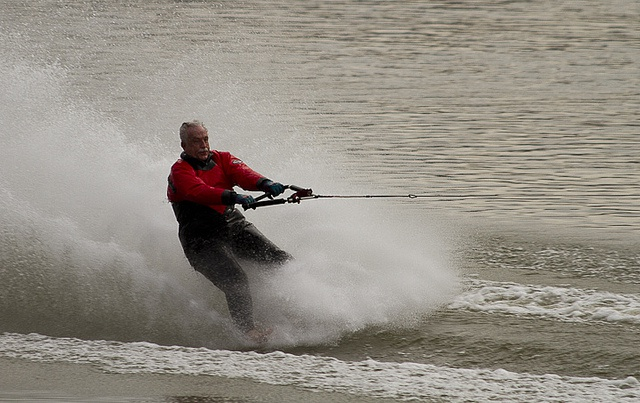Describe the objects in this image and their specific colors. I can see people in darkgray, black, maroon, and gray tones in this image. 